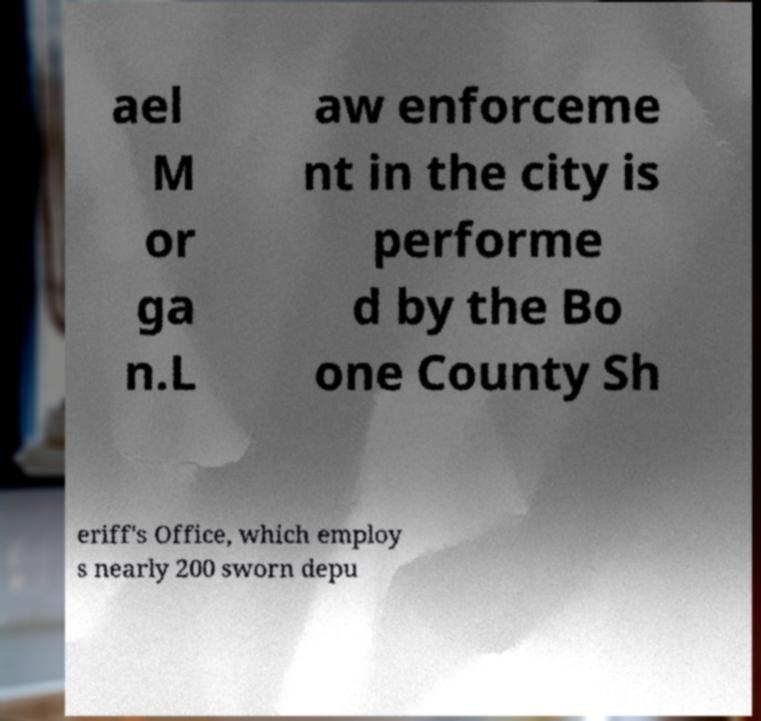Please read and relay the text visible in this image. What does it say? ael M or ga n.L aw enforceme nt in the city is performe d by the Bo one County Sh eriff's Office, which employ s nearly 200 sworn depu 